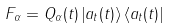<formula> <loc_0><loc_0><loc_500><loc_500>F _ { \alpha } = Q _ { \alpha } ( t ) \left | a _ { t } ( t ) \right \rangle \left \langle a _ { t } ( t ) \right |</formula> 